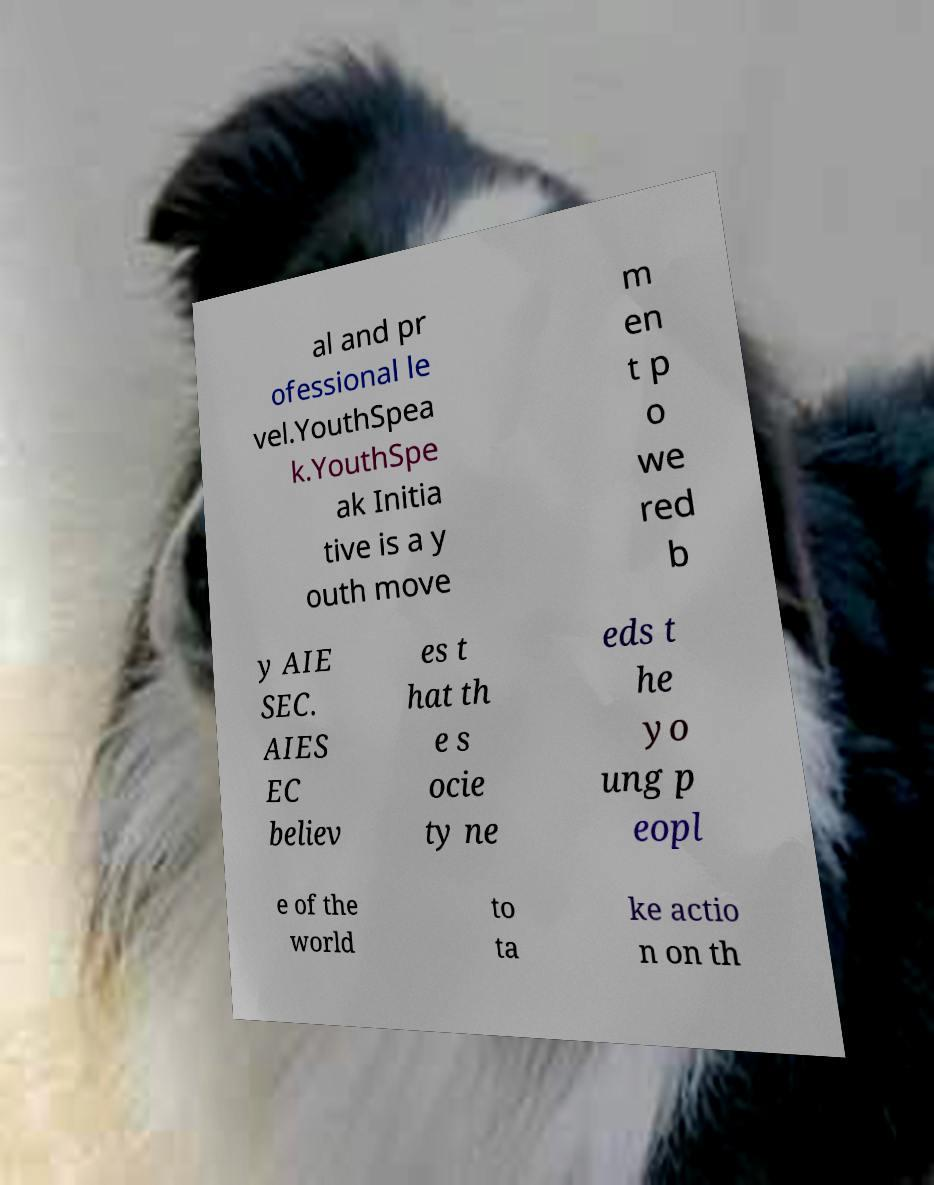Could you assist in decoding the text presented in this image and type it out clearly? al and pr ofessional le vel.YouthSpea k.YouthSpe ak Initia tive is a y outh move m en t p o we red b y AIE SEC. AIES EC believ es t hat th e s ocie ty ne eds t he yo ung p eopl e of the world to ta ke actio n on th 